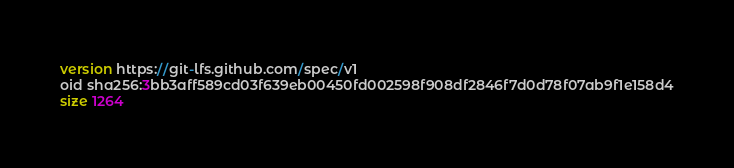Convert code to text. <code><loc_0><loc_0><loc_500><loc_500><_SQL_>version https://git-lfs.github.com/spec/v1
oid sha256:3bb3aff589cd03f639eb00450fd002598f908df2846f7d0d78f07ab9f1e158d4
size 1264
</code> 